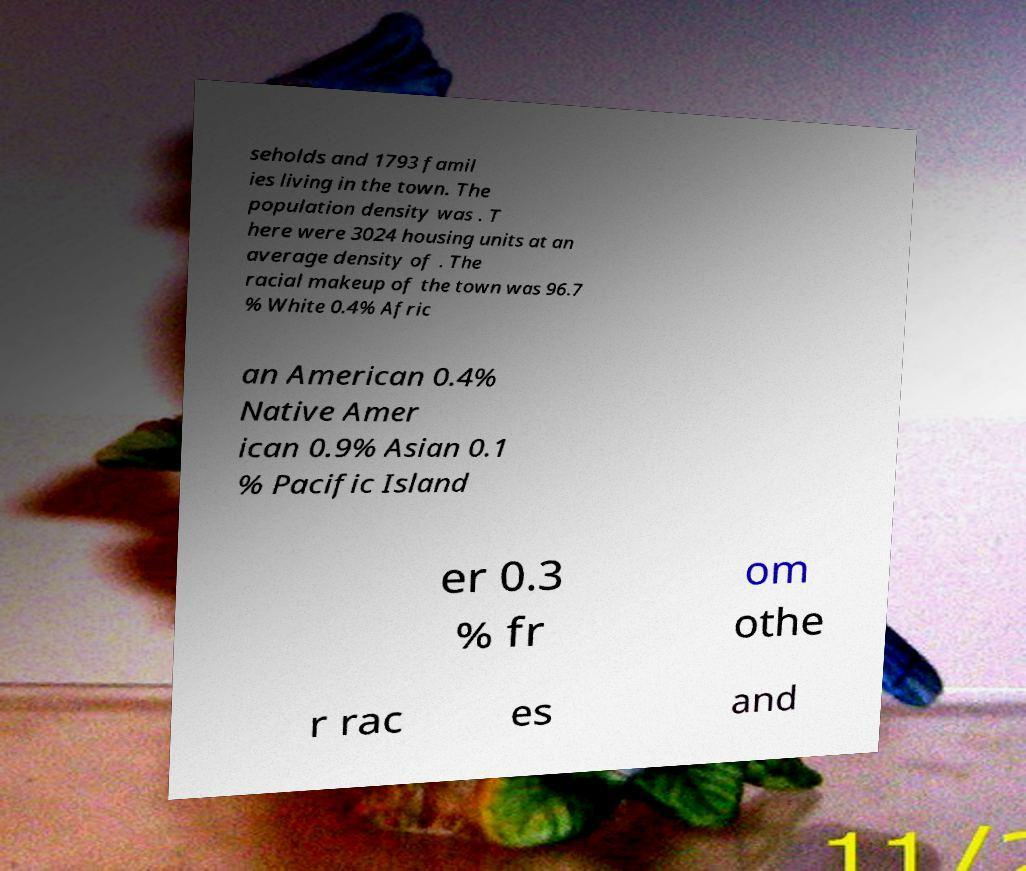Can you read and provide the text displayed in the image?This photo seems to have some interesting text. Can you extract and type it out for me? seholds and 1793 famil ies living in the town. The population density was . T here were 3024 housing units at an average density of . The racial makeup of the town was 96.7 % White 0.4% Afric an American 0.4% Native Amer ican 0.9% Asian 0.1 % Pacific Island er 0.3 % fr om othe r rac es and 